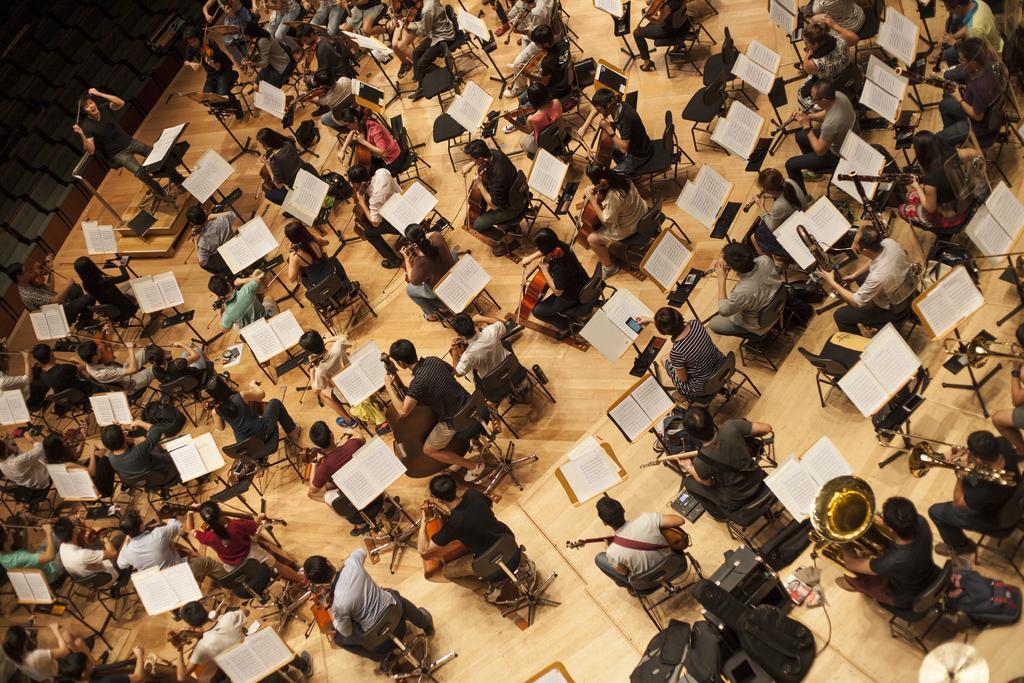Please provide a concise description of this image. In the picture the image is taken from the top view, there are many people sitting on the chairs and playing different music instruments and there are music notations kept in front of them and on the left side there is a person teaching them to play the instruments. 